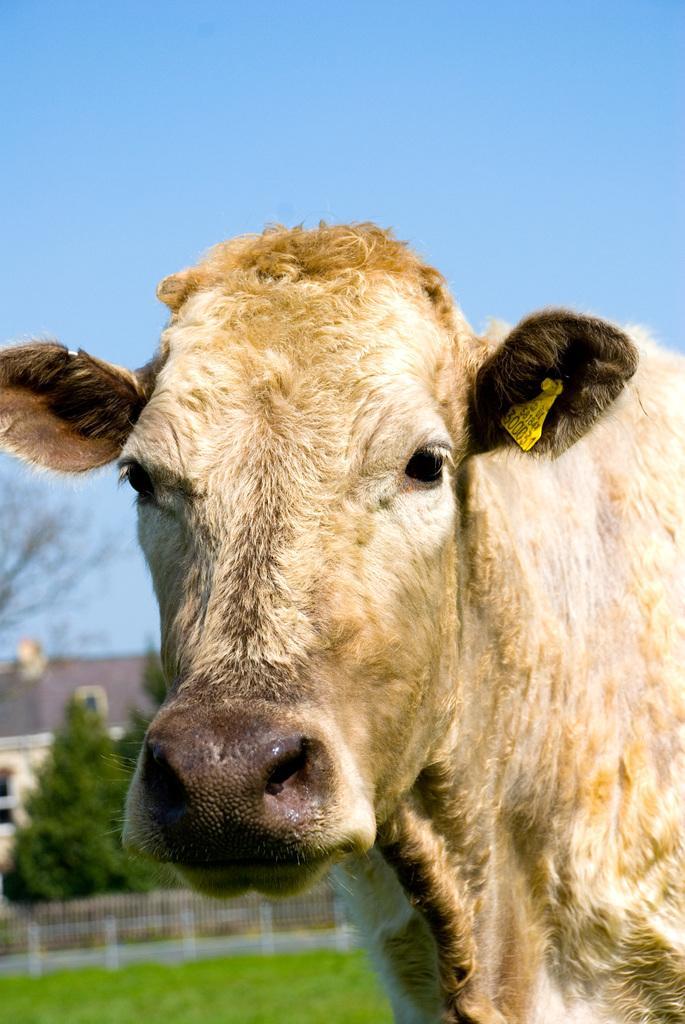Please provide a concise description of this image. In this picture there is a cow. In the background I can see the fencing, trees, plants and building. At the top I can see the sky. 